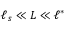Convert formula to latex. <formula><loc_0><loc_0><loc_500><loc_500>\ell _ { s } \ll L \ll \ell ^ { \ast }</formula> 